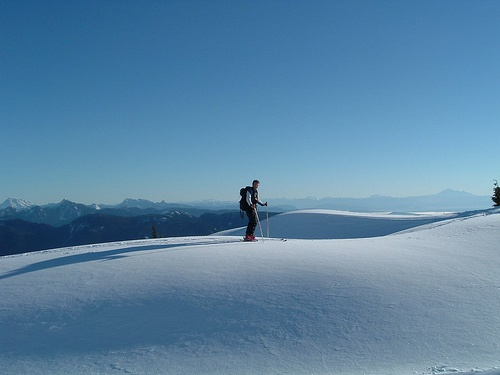Describe the objects in this image and their specific colors. I can see people in blue, black, gray, navy, and darkgray tones, backpack in blue, black, and navy tones, and skis in blue, darkgray, and gray tones in this image. 